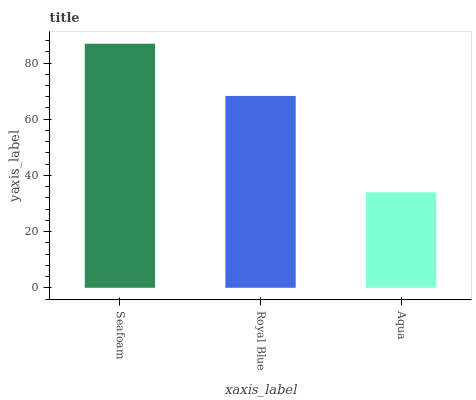Is Aqua the minimum?
Answer yes or no. Yes. Is Seafoam the maximum?
Answer yes or no. Yes. Is Royal Blue the minimum?
Answer yes or no. No. Is Royal Blue the maximum?
Answer yes or no. No. Is Seafoam greater than Royal Blue?
Answer yes or no. Yes. Is Royal Blue less than Seafoam?
Answer yes or no. Yes. Is Royal Blue greater than Seafoam?
Answer yes or no. No. Is Seafoam less than Royal Blue?
Answer yes or no. No. Is Royal Blue the high median?
Answer yes or no. Yes. Is Royal Blue the low median?
Answer yes or no. Yes. Is Aqua the high median?
Answer yes or no. No. Is Aqua the low median?
Answer yes or no. No. 